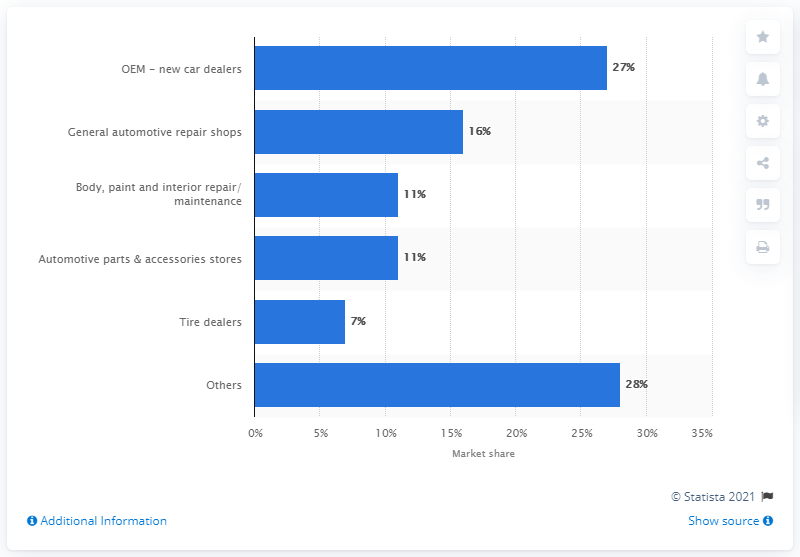Indicate a few pertinent items in this graphic. The sum of the first three small bars is 29. The percentage value for tire dealers is 7. 